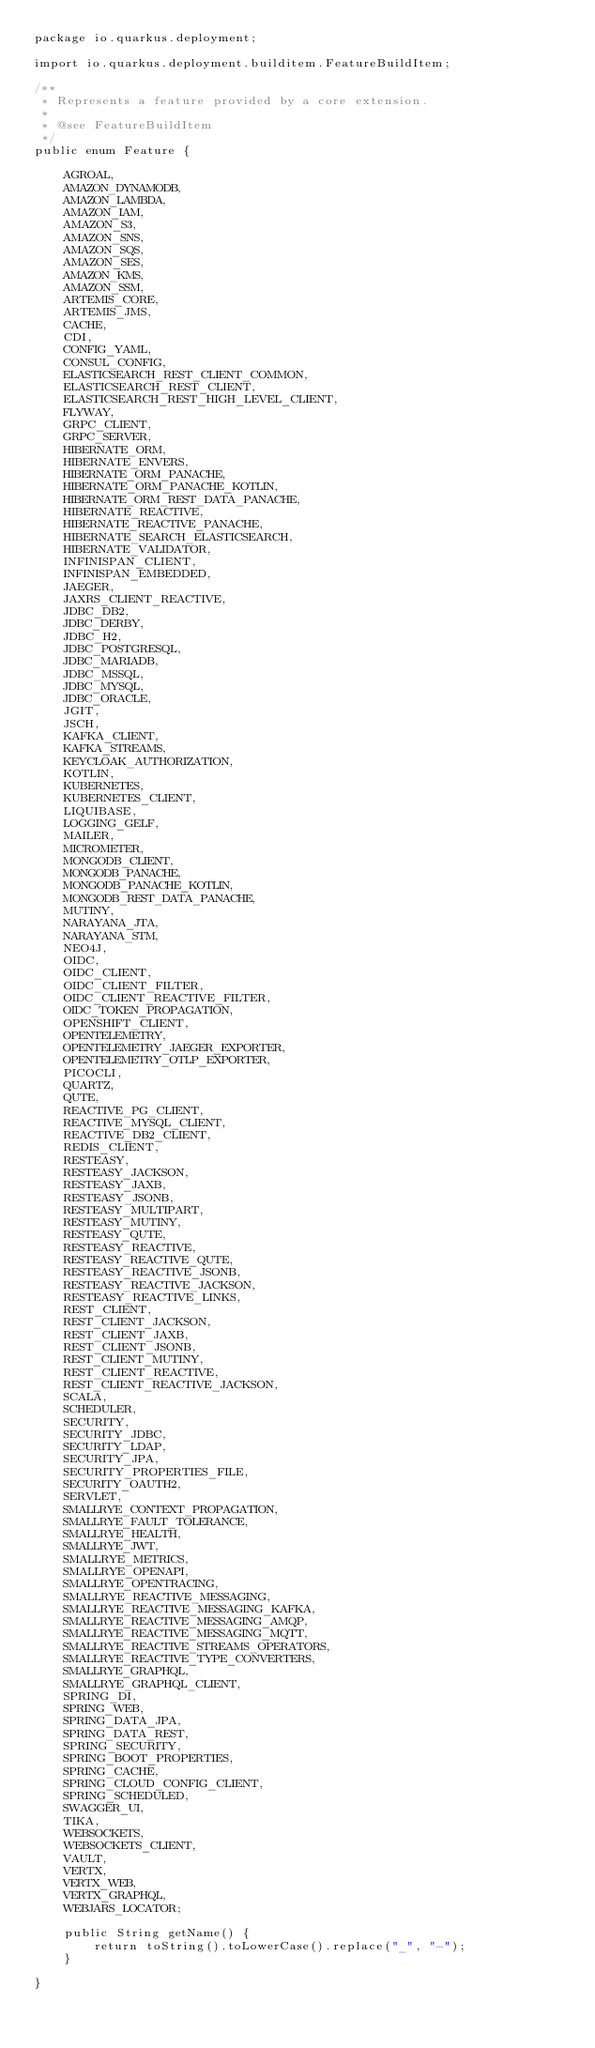Convert code to text. <code><loc_0><loc_0><loc_500><loc_500><_Java_>package io.quarkus.deployment;

import io.quarkus.deployment.builditem.FeatureBuildItem;

/**
 * Represents a feature provided by a core extension.
 *
 * @see FeatureBuildItem
 */
public enum Feature {

    AGROAL,
    AMAZON_DYNAMODB,
    AMAZON_LAMBDA,
    AMAZON_IAM,
    AMAZON_S3,
    AMAZON_SNS,
    AMAZON_SQS,
    AMAZON_SES,
    AMAZON_KMS,
    AMAZON_SSM,
    ARTEMIS_CORE,
    ARTEMIS_JMS,
    CACHE,
    CDI,
    CONFIG_YAML,
    CONSUL_CONFIG,
    ELASTICSEARCH_REST_CLIENT_COMMON,
    ELASTICSEARCH_REST_CLIENT,
    ELASTICSEARCH_REST_HIGH_LEVEL_CLIENT,
    FLYWAY,
    GRPC_CLIENT,
    GRPC_SERVER,
    HIBERNATE_ORM,
    HIBERNATE_ENVERS,
    HIBERNATE_ORM_PANACHE,
    HIBERNATE_ORM_PANACHE_KOTLIN,
    HIBERNATE_ORM_REST_DATA_PANACHE,
    HIBERNATE_REACTIVE,
    HIBERNATE_REACTIVE_PANACHE,
    HIBERNATE_SEARCH_ELASTICSEARCH,
    HIBERNATE_VALIDATOR,
    INFINISPAN_CLIENT,
    INFINISPAN_EMBEDDED,
    JAEGER,
    JAXRS_CLIENT_REACTIVE,
    JDBC_DB2,
    JDBC_DERBY,
    JDBC_H2,
    JDBC_POSTGRESQL,
    JDBC_MARIADB,
    JDBC_MSSQL,
    JDBC_MYSQL,
    JDBC_ORACLE,
    JGIT,
    JSCH,
    KAFKA_CLIENT,
    KAFKA_STREAMS,
    KEYCLOAK_AUTHORIZATION,
    KOTLIN,
    KUBERNETES,
    KUBERNETES_CLIENT,
    LIQUIBASE,
    LOGGING_GELF,
    MAILER,
    MICROMETER,
    MONGODB_CLIENT,
    MONGODB_PANACHE,
    MONGODB_PANACHE_KOTLIN,
    MONGODB_REST_DATA_PANACHE,
    MUTINY,
    NARAYANA_JTA,
    NARAYANA_STM,
    NEO4J,
    OIDC,
    OIDC_CLIENT,
    OIDC_CLIENT_FILTER,
    OIDC_CLIENT_REACTIVE_FILTER,
    OIDC_TOKEN_PROPAGATION,
    OPENSHIFT_CLIENT,
    OPENTELEMETRY,
    OPENTELEMETRY_JAEGER_EXPORTER,
    OPENTELEMETRY_OTLP_EXPORTER,
    PICOCLI,
    QUARTZ,
    QUTE,
    REACTIVE_PG_CLIENT,
    REACTIVE_MYSQL_CLIENT,
    REACTIVE_DB2_CLIENT,
    REDIS_CLIENT,
    RESTEASY,
    RESTEASY_JACKSON,
    RESTEASY_JAXB,
    RESTEASY_JSONB,
    RESTEASY_MULTIPART,
    RESTEASY_MUTINY,
    RESTEASY_QUTE,
    RESTEASY_REACTIVE,
    RESTEASY_REACTIVE_QUTE,
    RESTEASY_REACTIVE_JSONB,
    RESTEASY_REACTIVE_JACKSON,
    RESTEASY_REACTIVE_LINKS,
    REST_CLIENT,
    REST_CLIENT_JACKSON,
    REST_CLIENT_JAXB,
    REST_CLIENT_JSONB,
    REST_CLIENT_MUTINY,
    REST_CLIENT_REACTIVE,
    REST_CLIENT_REACTIVE_JACKSON,
    SCALA,
    SCHEDULER,
    SECURITY,
    SECURITY_JDBC,
    SECURITY_LDAP,
    SECURITY_JPA,
    SECURITY_PROPERTIES_FILE,
    SECURITY_OAUTH2,
    SERVLET,
    SMALLRYE_CONTEXT_PROPAGATION,
    SMALLRYE_FAULT_TOLERANCE,
    SMALLRYE_HEALTH,
    SMALLRYE_JWT,
    SMALLRYE_METRICS,
    SMALLRYE_OPENAPI,
    SMALLRYE_OPENTRACING,
    SMALLRYE_REACTIVE_MESSAGING,
    SMALLRYE_REACTIVE_MESSAGING_KAFKA,
    SMALLRYE_REACTIVE_MESSAGING_AMQP,
    SMALLRYE_REACTIVE_MESSAGING_MQTT,
    SMALLRYE_REACTIVE_STREAMS_OPERATORS,
    SMALLRYE_REACTIVE_TYPE_CONVERTERS,
    SMALLRYE_GRAPHQL,
    SMALLRYE_GRAPHQL_CLIENT,
    SPRING_DI,
    SPRING_WEB,
    SPRING_DATA_JPA,
    SPRING_DATA_REST,
    SPRING_SECURITY,
    SPRING_BOOT_PROPERTIES,
    SPRING_CACHE,
    SPRING_CLOUD_CONFIG_CLIENT,
    SPRING_SCHEDULED,
    SWAGGER_UI,
    TIKA,
    WEBSOCKETS,
    WEBSOCKETS_CLIENT,
    VAULT,
    VERTX,
    VERTX_WEB,
    VERTX_GRAPHQL,
    WEBJARS_LOCATOR;

    public String getName() {
        return toString().toLowerCase().replace("_", "-");
    }

}
</code> 